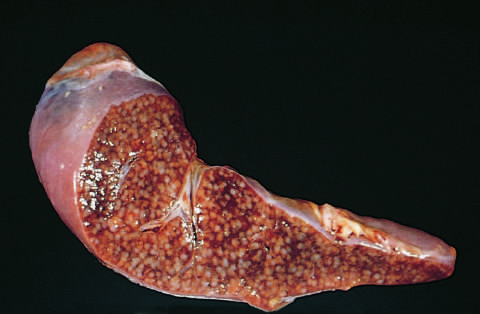does the congested portion of the ileum show numerous gray-white granulomas?
Answer the question using a single word or phrase. No 